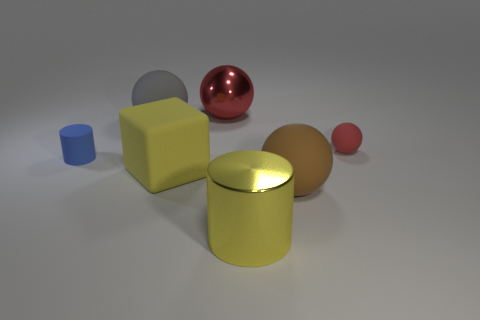Subtract all gray balls. Subtract all yellow cylinders. How many balls are left? 3 Subtract all purple cubes. How many green spheres are left? 0 Add 4 large objects. How many large grays exist? 0 Subtract all yellow blocks. Subtract all tiny matte cylinders. How many objects are left? 5 Add 1 big gray balls. How many big gray balls are left? 2 Add 1 things. How many things exist? 8 Add 1 spheres. How many objects exist? 8 Subtract all red spheres. How many spheres are left? 2 Subtract all shiny balls. How many balls are left? 3 Subtract 0 brown cylinders. How many objects are left? 7 